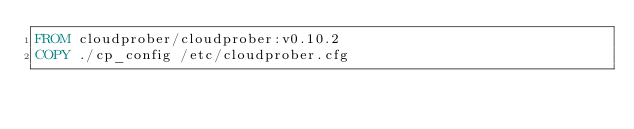<code> <loc_0><loc_0><loc_500><loc_500><_Dockerfile_>FROM cloudprober/cloudprober:v0.10.2
COPY ./cp_config /etc/cloudprober.cfg
</code> 